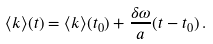<formula> <loc_0><loc_0><loc_500><loc_500>\langle k \rangle ( t ) = \langle k \rangle ( t _ { 0 } ) + \frac { \delta \omega } { a } ( t - t _ { 0 } ) \, .</formula> 